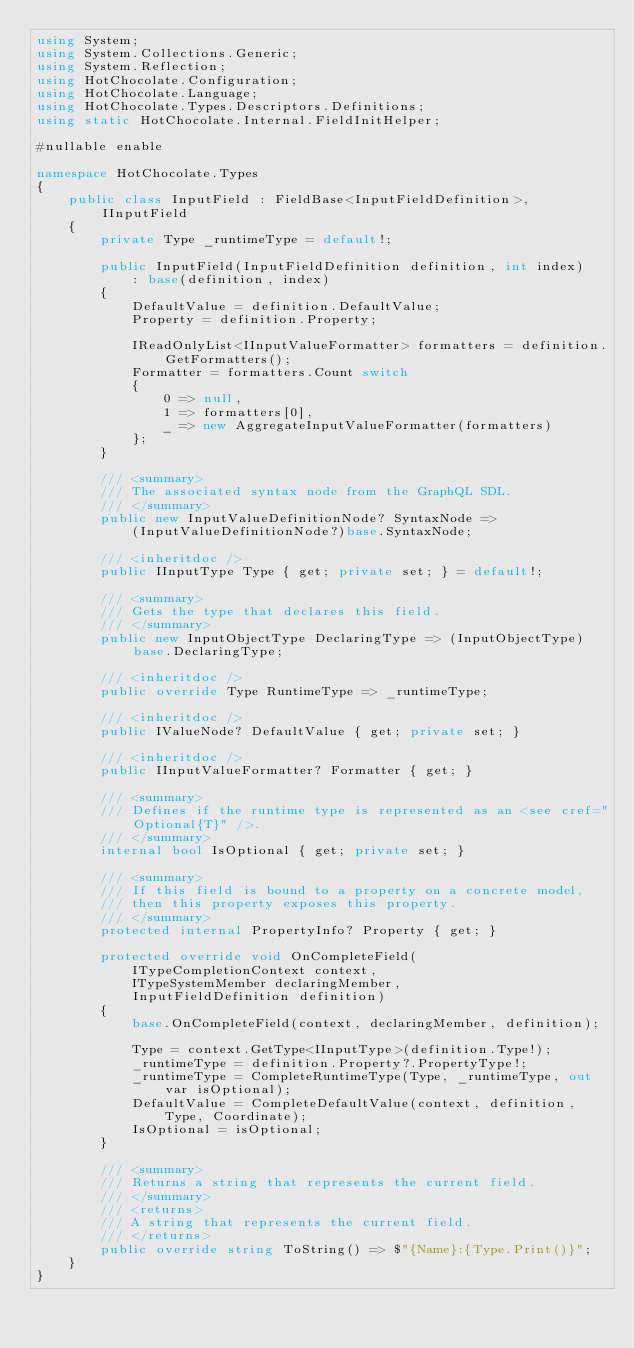<code> <loc_0><loc_0><loc_500><loc_500><_C#_>using System;
using System.Collections.Generic;
using System.Reflection;
using HotChocolate.Configuration;
using HotChocolate.Language;
using HotChocolate.Types.Descriptors.Definitions;
using static HotChocolate.Internal.FieldInitHelper;

#nullable enable

namespace HotChocolate.Types
{
    public class InputField : FieldBase<InputFieldDefinition>, IInputField
    {
        private Type _runtimeType = default!;

        public InputField(InputFieldDefinition definition, int index)
            : base(definition, index)
        {
            DefaultValue = definition.DefaultValue;
            Property = definition.Property;

            IReadOnlyList<IInputValueFormatter> formatters = definition.GetFormatters();
            Formatter = formatters.Count switch
            {
                0 => null,
                1 => formatters[0],
                _ => new AggregateInputValueFormatter(formatters)
            };
        }

        /// <summary>
        /// The associated syntax node from the GraphQL SDL.
        /// </summary>
        public new InputValueDefinitionNode? SyntaxNode =>
            (InputValueDefinitionNode?)base.SyntaxNode;

        /// <inheritdoc />
        public IInputType Type { get; private set; } = default!;

        /// <summary>
        /// Gets the type that declares this field.
        /// </summary>
        public new InputObjectType DeclaringType => (InputObjectType)base.DeclaringType;

        /// <inheritdoc />
        public override Type RuntimeType => _runtimeType;

        /// <inheritdoc />
        public IValueNode? DefaultValue { get; private set; }

        /// <inheritdoc />
        public IInputValueFormatter? Formatter { get; }

        /// <summary>
        /// Defines if the runtime type is represented as an <see cref="Optional{T}" />.
        /// </summary>
        internal bool IsOptional { get; private set; }

        /// <summary>
        /// If this field is bound to a property on a concrete model,
        /// then this property exposes this property.
        /// </summary>
        protected internal PropertyInfo? Property { get; }

        protected override void OnCompleteField(
            ITypeCompletionContext context,
            ITypeSystemMember declaringMember,
            InputFieldDefinition definition)
        {
            base.OnCompleteField(context, declaringMember, definition);

            Type = context.GetType<IInputType>(definition.Type!);
            _runtimeType = definition.Property?.PropertyType!;
            _runtimeType = CompleteRuntimeType(Type, _runtimeType, out var isOptional);
            DefaultValue = CompleteDefaultValue(context, definition, Type, Coordinate);
            IsOptional = isOptional;
        }

        /// <summary>
        /// Returns a string that represents the current field.
        /// </summary>
        /// <returns>
        /// A string that represents the current field.
        /// </returns>
        public override string ToString() => $"{Name}:{Type.Print()}";
    }
}
</code> 